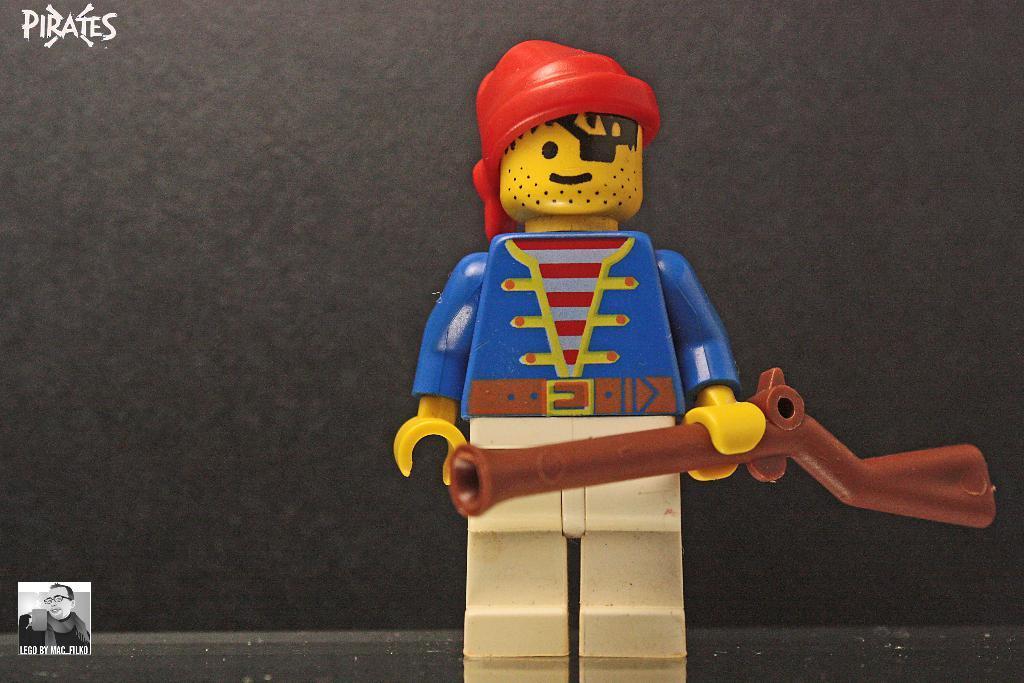How would you summarize this image in a sentence or two? This image consists of a puppet made up of plastic. And there is a gun. The background is in black color. 